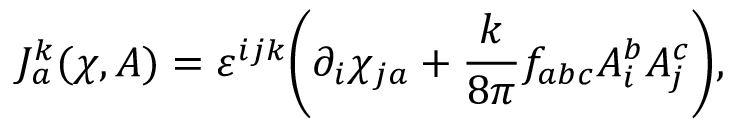Convert formula to latex. <formula><loc_0><loc_0><loc_500><loc_500>J _ { a } ^ { k } ( \chi , A ) = \varepsilon ^ { i j k } \left ( \partial _ { i } \chi _ { j a } + { \frac { k } { 8 \pi } } f _ { a b c } A _ { i } ^ { b } A _ { j } ^ { c } \right ) ,</formula> 